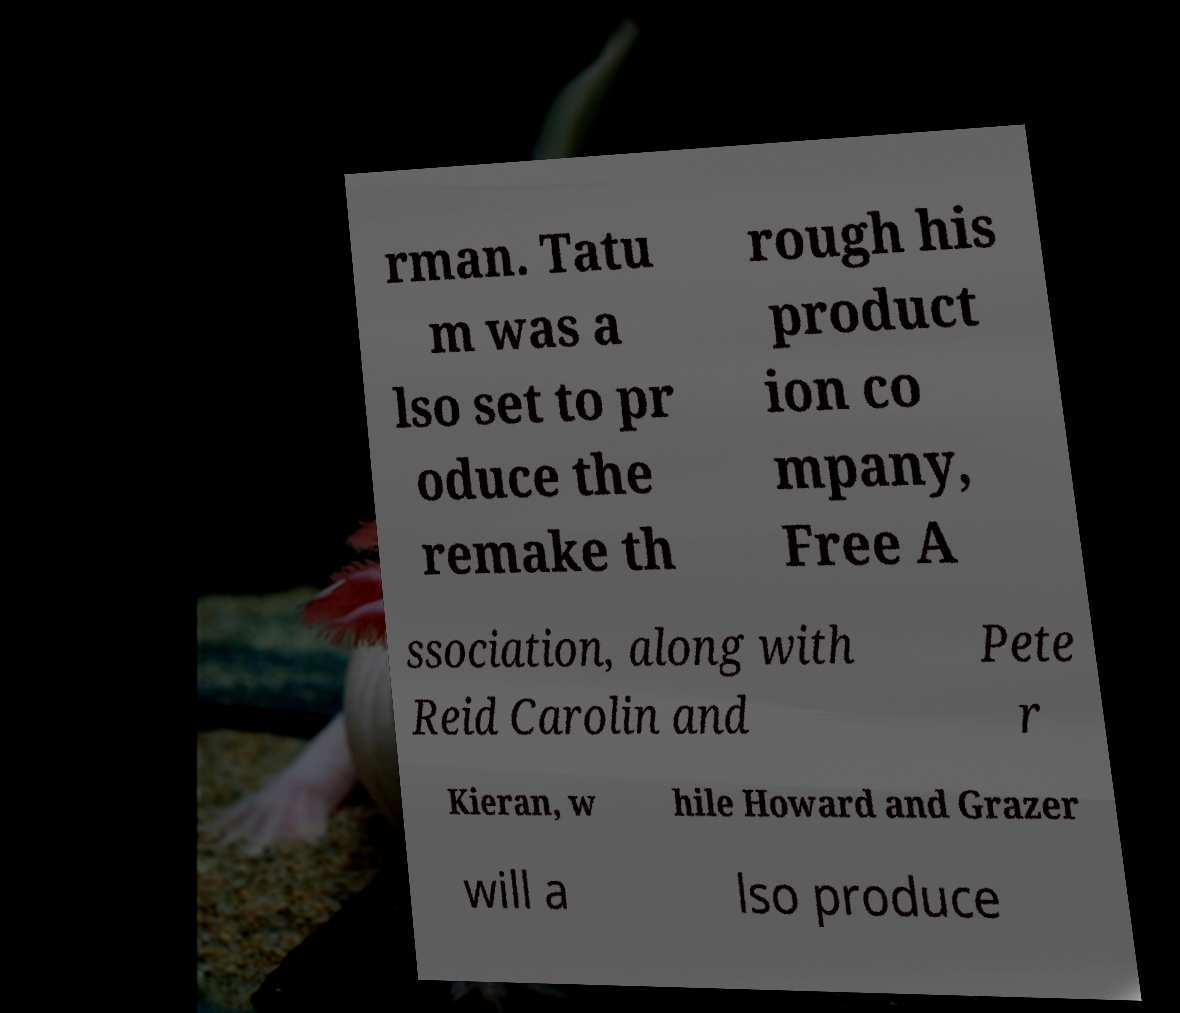Please read and relay the text visible in this image. What does it say? rman. Tatu m was a lso set to pr oduce the remake th rough his product ion co mpany, Free A ssociation, along with Reid Carolin and Pete r Kieran, w hile Howard and Grazer will a lso produce 